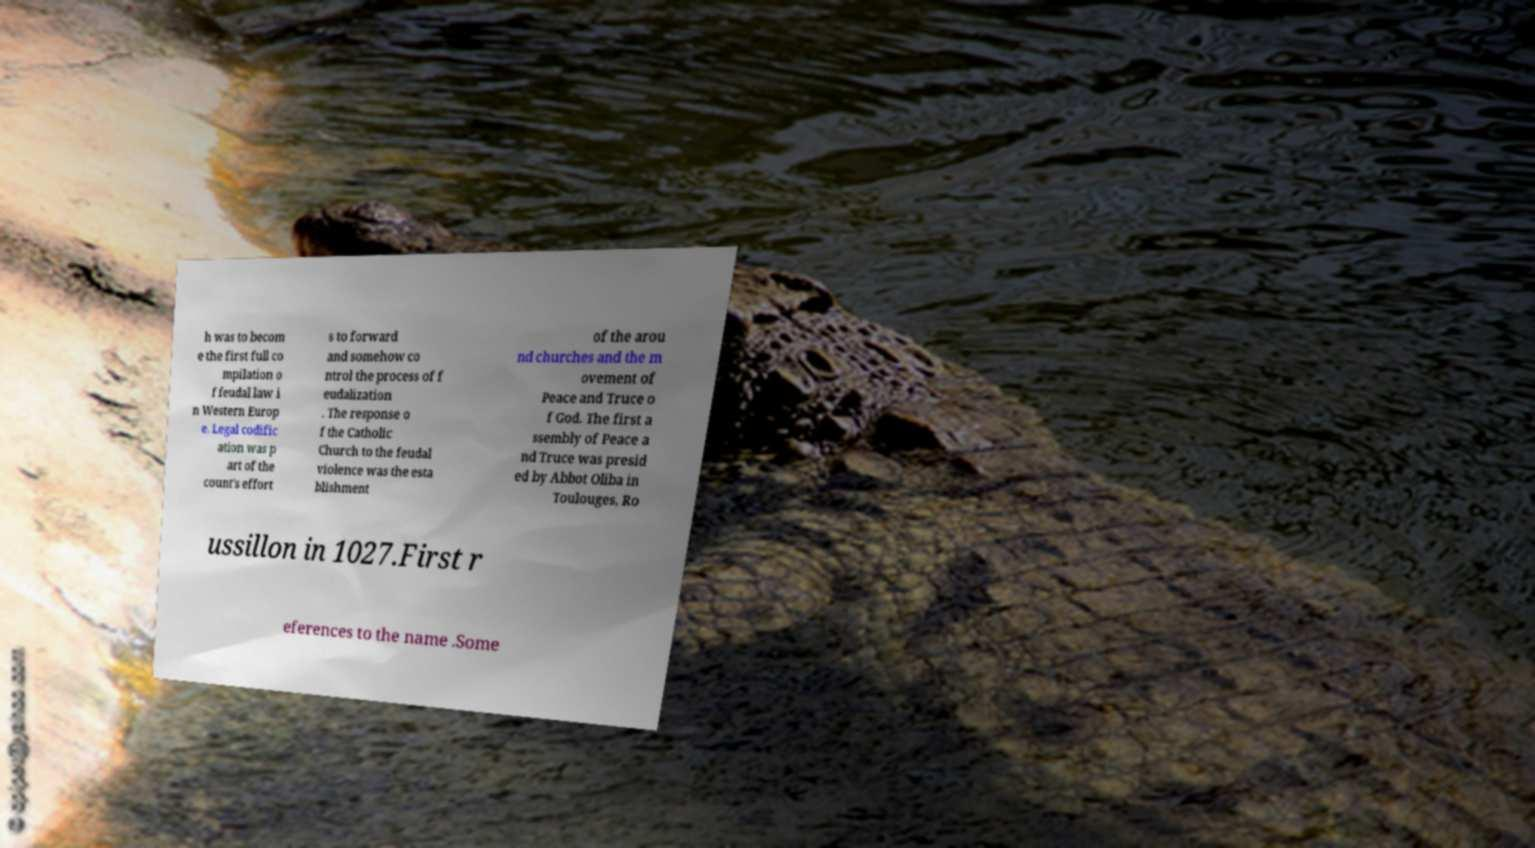There's text embedded in this image that I need extracted. Can you transcribe it verbatim? h was to becom e the first full co mpilation o f feudal law i n Western Europ e. Legal codific ation was p art of the count's effort s to forward and somehow co ntrol the process of f eudalization . The response o f the Catholic Church to the feudal violence was the esta blishment of the arou nd churches and the m ovement of Peace and Truce o f God. The first a ssembly of Peace a nd Truce was presid ed by Abbot Oliba in Toulouges, Ro ussillon in 1027.First r eferences to the name .Some 